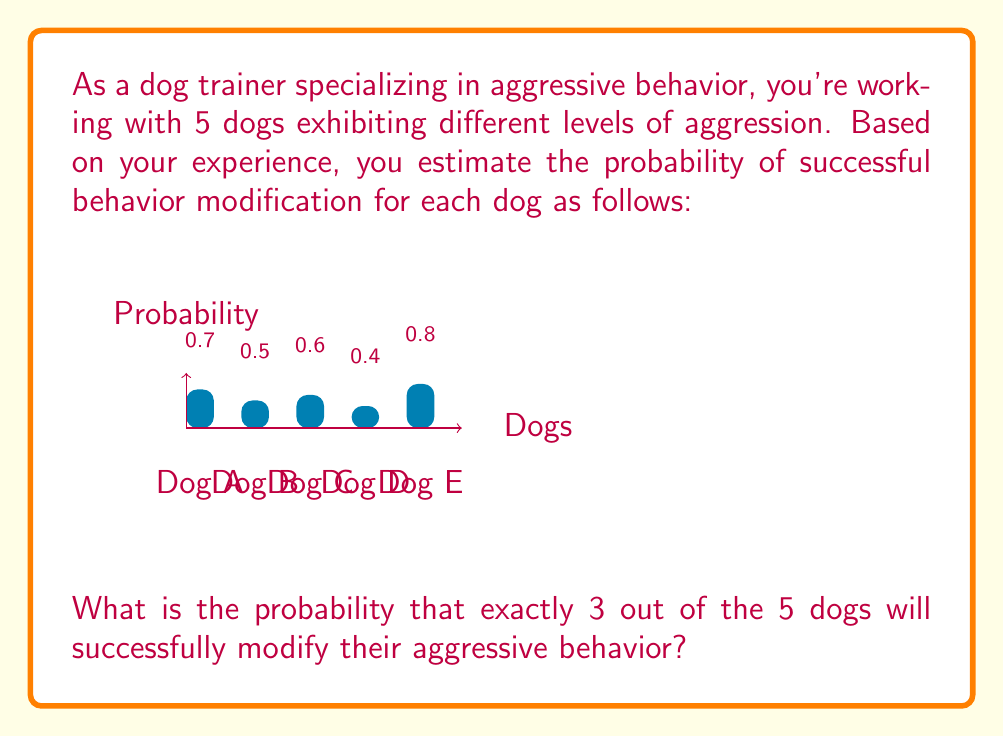Teach me how to tackle this problem. To solve this problem, we'll use the concept of binomial probability. The binomial probability formula is:

$$ P(X = k) = \binom{n}{k} p^k (1-p)^{n-k} $$

Where:
- $n$ is the total number of trials (in this case, 5 dogs)
- $k$ is the number of successes we're interested in (3 dogs)
- $p$ is the probability of success for each trial

However, in this case, each dog has a different probability of success. So we need to use a more advanced technique called the Poisson binomial distribution.

Steps:
1) List all possible combinations of 3 successful dogs out of 5:
   (A,B,C), (A,B,D), (A,B,E), (A,C,D), (A,C,E), (A,D,E), (B,C,D), (B,C,E), (B,D,E), (C,D,E)

2) For each combination, calculate the probability of those 3 succeeding and the other 2 failing:

   For (A,B,C): $0.7 \times 0.5 \times 0.6 \times (1-0.4) \times (1-0.8) = 0.0252$
   For (A,B,D): $0.7 \times 0.5 \times (1-0.6) \times 0.4 \times (1-0.8) = 0.0112$
   For (A,B,E): $0.7 \times 0.5 \times (1-0.6) \times (1-0.4) \times 0.8 = 0.0672$
   For (A,C,D): $0.7 \times (1-0.5) \times 0.6 \times 0.4 \times (1-0.8) = 0.0168$
   For (A,C,E): $0.7 \times (1-0.5) \times 0.6 \times (1-0.4) \times 0.8 = 0.0806$
   For (A,D,E): $0.7 \times (1-0.5) \times (1-0.6) \times 0.4 \times 0.8 = 0.0448$
   For (B,C,D): $(1-0.7) \times 0.5 \times 0.6 \times 0.4 \times (1-0.8) = 0.0072$
   For (B,C,E): $(1-0.7) \times 0.5 \times 0.6 \times (1-0.4) \times 0.8 = 0.0346$
   For (B,D,E): $(1-0.7) \times 0.5 \times (1-0.6) \times 0.4 \times 0.8 = 0.0192$
   For (C,D,E): $(1-0.7) \times (1-0.5) \times 0.6 \times 0.4 \times 0.8 = 0.0288$

3) Sum all these probabilities:

   $0.0252 + 0.0112 + 0.0672 + 0.0168 + 0.0806 + 0.0448 + 0.0072 + 0.0346 + 0.0192 + 0.0288 = 0.3356$

Therefore, the probability of exactly 3 out of the 5 dogs successfully modifying their aggressive behavior is 0.3356 or about 33.56%.
Answer: 0.3356 